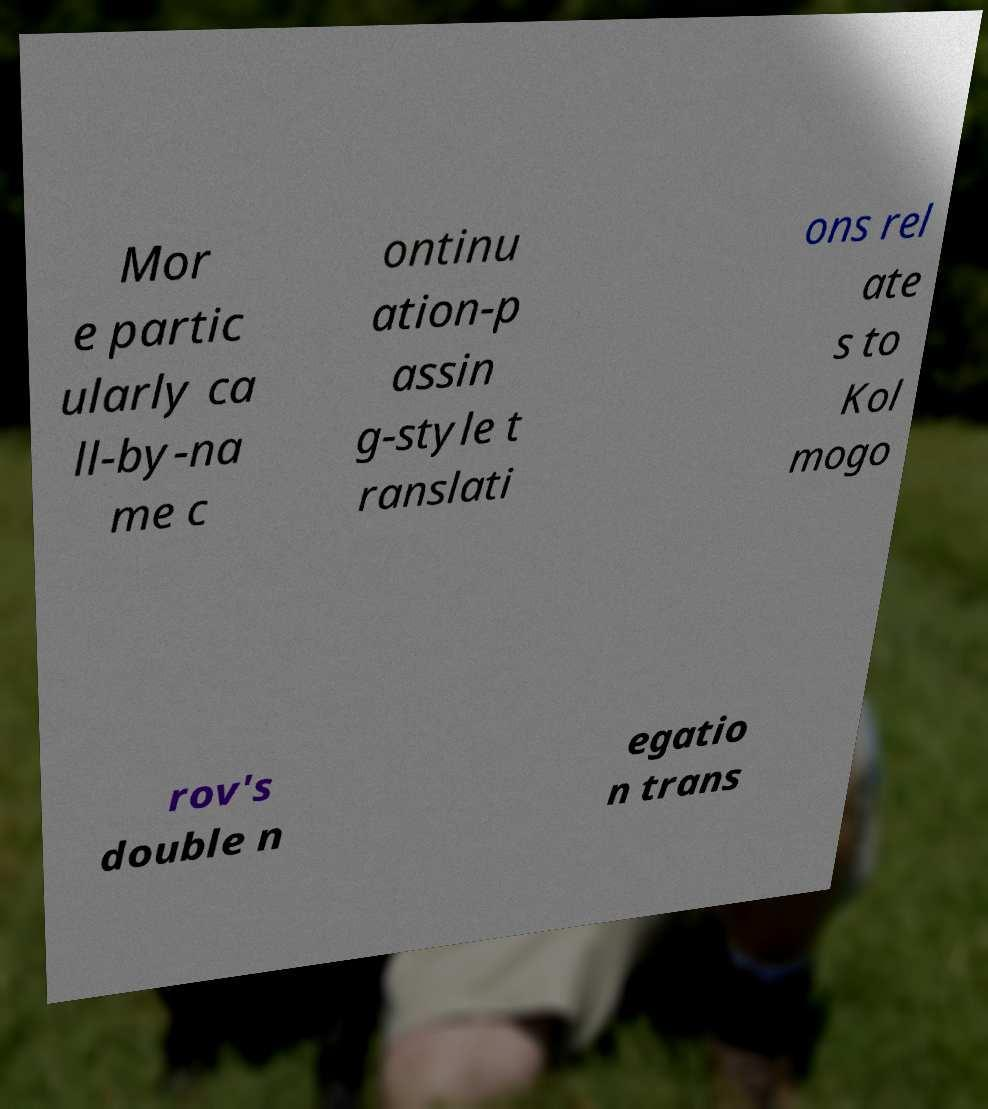Can you read and provide the text displayed in the image?This photo seems to have some interesting text. Can you extract and type it out for me? Mor e partic ularly ca ll-by-na me c ontinu ation-p assin g-style t ranslati ons rel ate s to Kol mogo rov's double n egatio n trans 